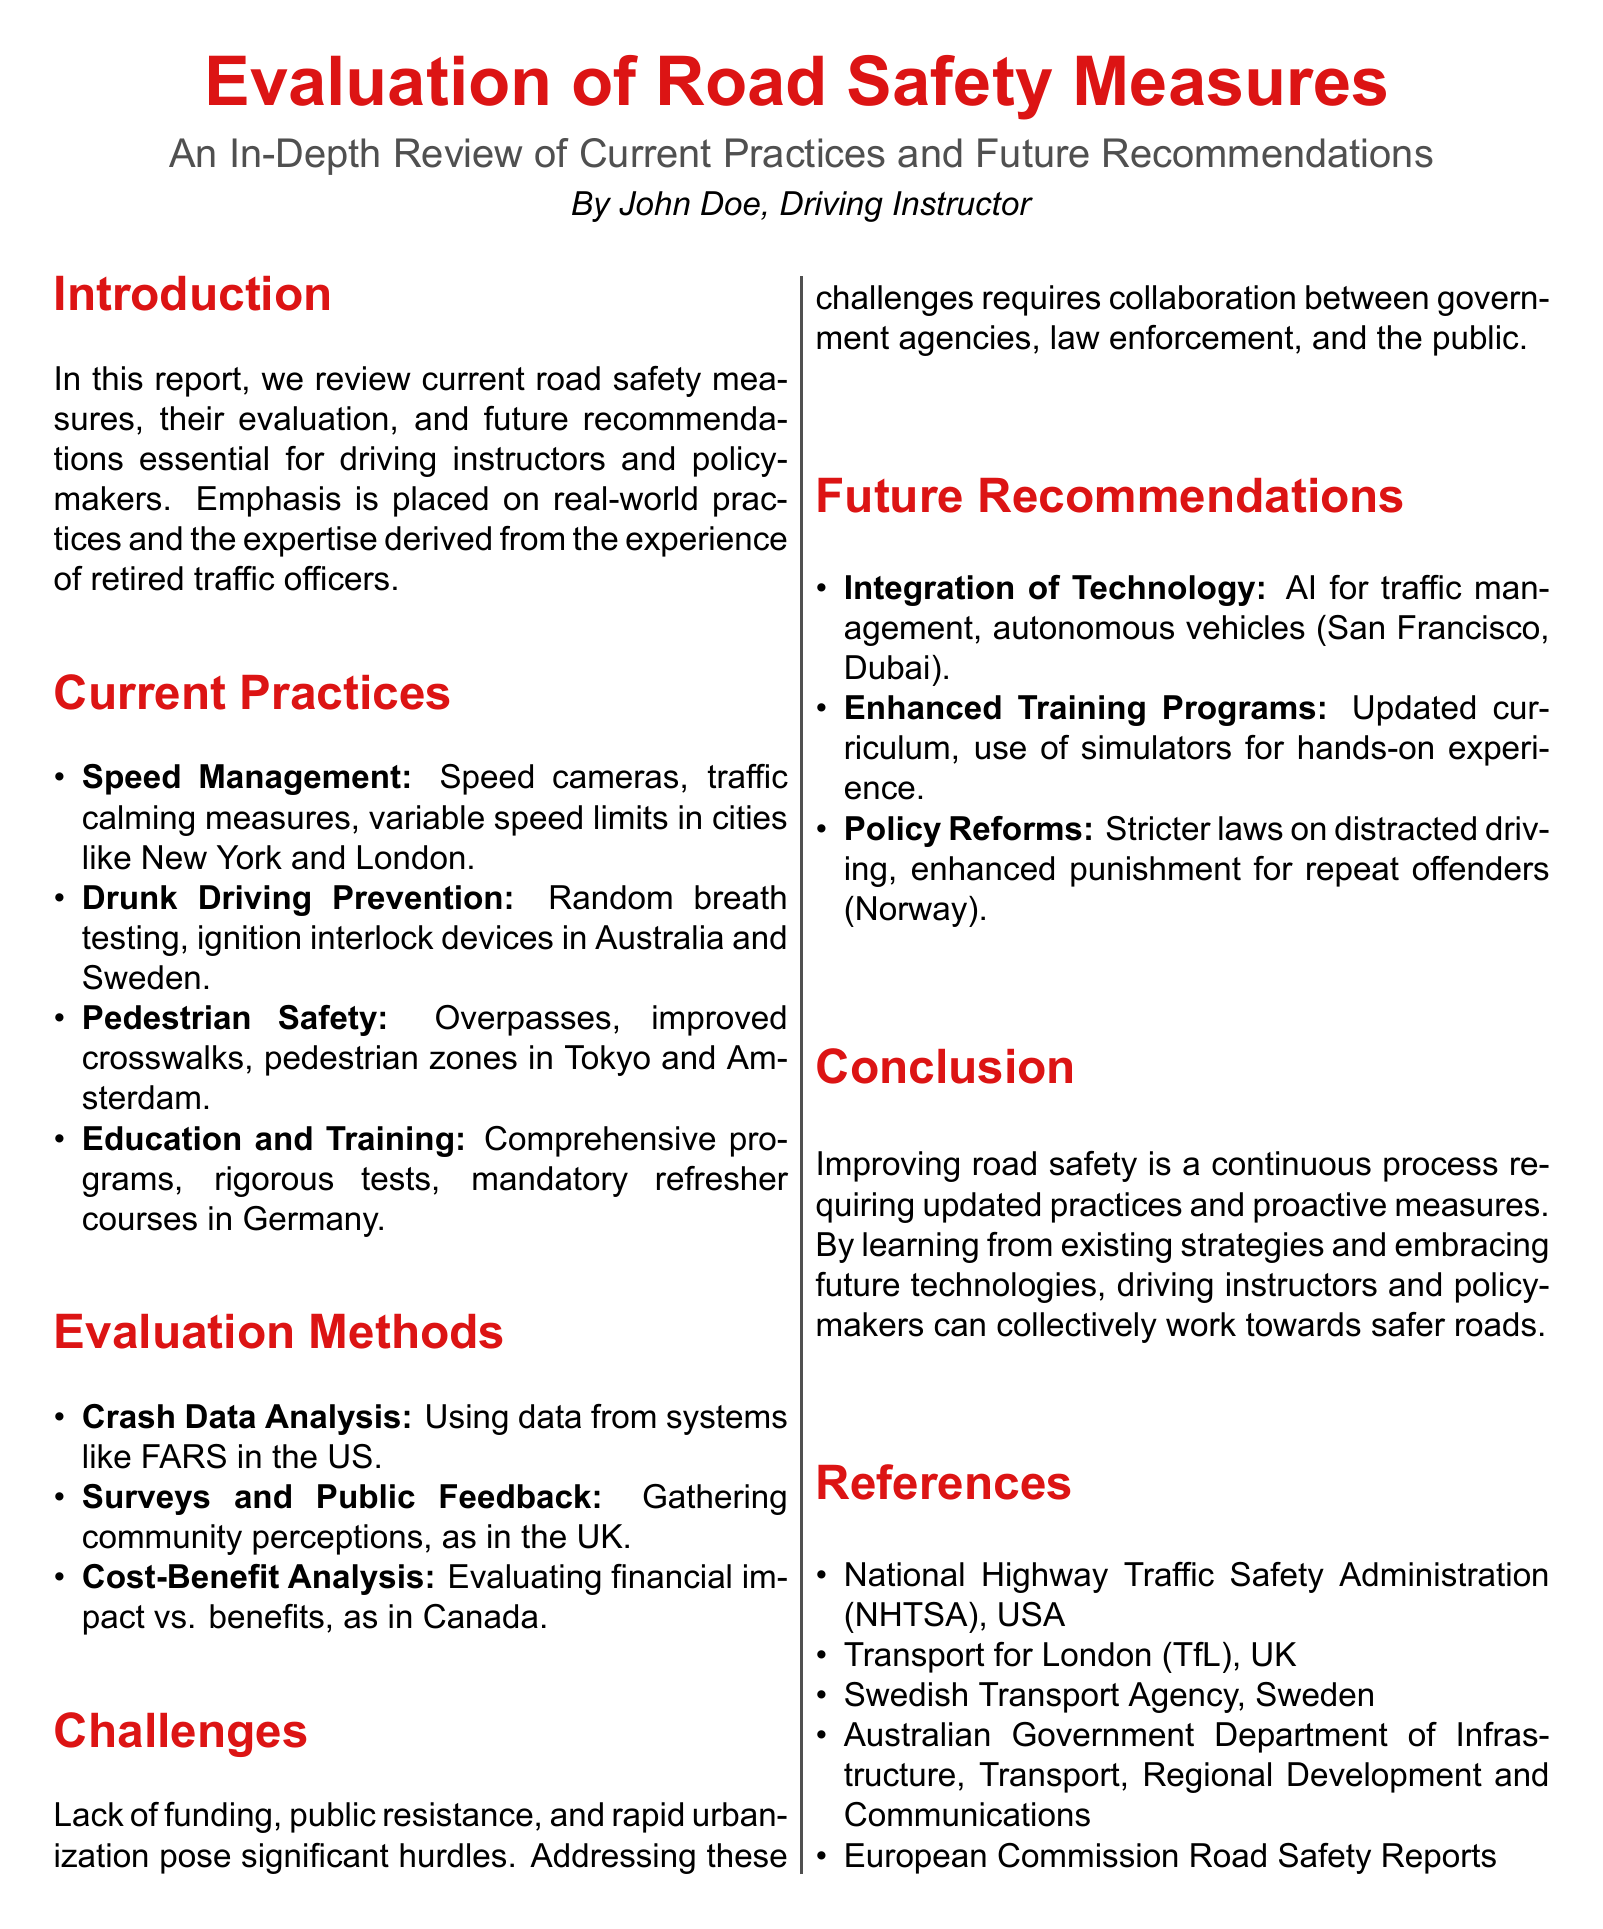What is the main focus of the report? The main focus of the report is the evaluation of road safety measures and future recommendations.
Answer: Evaluation of road safety measures Who authored the report? The report is authored by John Doe, who is identified as a driving instructor.
Answer: John Doe Which city is mentioned for its use of speed cameras? New York is mentioned as a city that utilizes speed cameras.
Answer: New York What challenge is highlighted regarding road safety? The document mentions the lack of funding as a significant challenge to road safety.
Answer: Lack of funding What technology is recommended for traffic management? The report recommends the integration of AI for traffic management.
Answer: AI Which country implements ignition interlock devices? Australia is identified as a country that uses ignition interlock devices.
Answer: Australia What educational practice is emphasized in Germany? Germany focuses on rigorous tests as part of its educational practices.
Answer: Rigorous tests What type of analysis is used to evaluate road safety measures? Crash data analysis is noted as a method for evaluation.
Answer: Crash data analysis What is one proposed future policy reform? The document suggests implementing stricter laws on distracted driving.
Answer: Stricter laws on distracted driving 